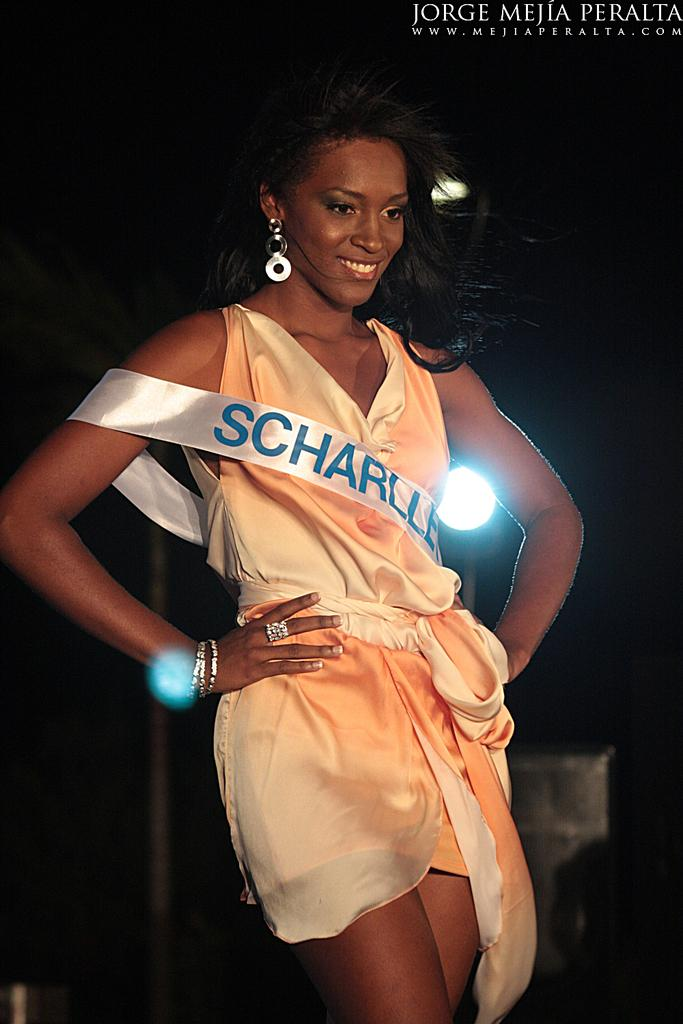Who is present in the image? There is a woman in the image. What is the woman wearing? The woman is wearing a cream-colored dress. Are there any accessories visible on the woman? Yes, the woman has a white-colored band on her. What can be seen in the background of the image? There is a light in the background of the image, and the background is dark. What day of the week is indicated on the calendar in the image? There is no calendar present in the image. What type of fruit is the woman holding in the image? There is no fruit, including a banana, visible in the image. 